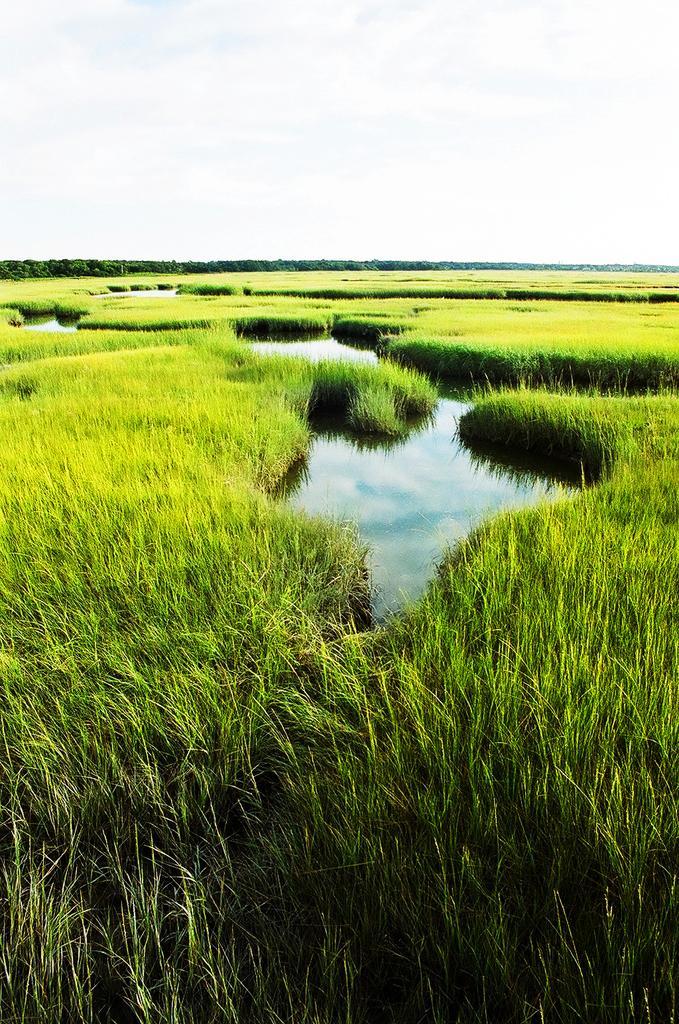Describe this image in one or two sentences. In this image I can see grass in green color, water, and sky in white color. 